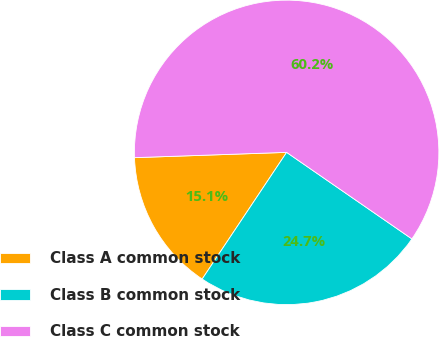Convert chart to OTSL. <chart><loc_0><loc_0><loc_500><loc_500><pie_chart><fcel>Class A common stock<fcel>Class B common stock<fcel>Class C common stock<nl><fcel>15.09%<fcel>24.74%<fcel>60.18%<nl></chart> 